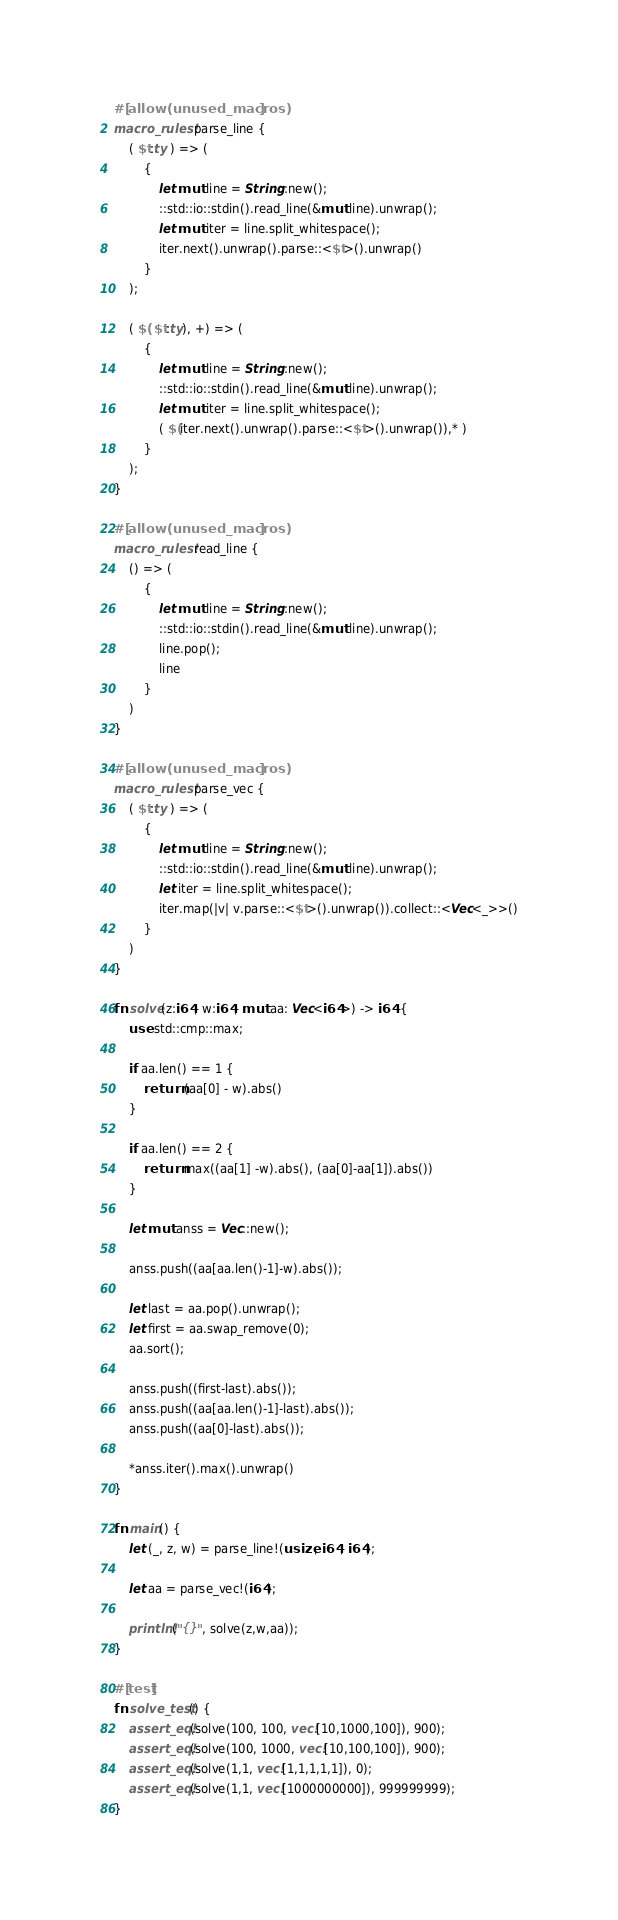<code> <loc_0><loc_0><loc_500><loc_500><_Rust_>#[allow(unused_macros)]
macro_rules! parse_line {
    ( $t:ty ) => (
        {
            let mut line = String::new();
            ::std::io::stdin().read_line(&mut line).unwrap();
            let mut iter = line.split_whitespace();
            iter.next().unwrap().parse::<$t>().unwrap()
        }
    );

    ( $( $t:ty), +) => (
        {
            let mut line = String::new();
            ::std::io::stdin().read_line(&mut line).unwrap();
            let mut iter = line.split_whitespace();
            ( $(iter.next().unwrap().parse::<$t>().unwrap()),* )
        }
    );
}

#[allow(unused_macros)]
macro_rules! read_line {
    () => (
        {
            let mut line = String::new();
            ::std::io::stdin().read_line(&mut line).unwrap();
            line.pop();
            line
        }
    )
}

#[allow(unused_macros)]
macro_rules! parse_vec {
    ( $t:ty ) => (
        {
            let mut line = String::new();
            ::std::io::stdin().read_line(&mut line).unwrap();
            let iter = line.split_whitespace();
            iter.map(|v| v.parse::<$t>().unwrap()).collect::<Vec<_>>()
        }
    )
}

fn solve(z:i64, w:i64, mut aa: Vec<i64>) -> i64 {
    use std::cmp::max;

    if aa.len() == 1 {
        return (aa[0] - w).abs()
    }

    if aa.len() == 2 {
        return max((aa[1] -w).abs(), (aa[0]-aa[1]).abs())
    }

    let mut anss = Vec::new();

    anss.push((aa[aa.len()-1]-w).abs());

    let last = aa.pop().unwrap();
    let first = aa.swap_remove(0);
    aa.sort();

    anss.push((first-last).abs());
    anss.push((aa[aa.len()-1]-last).abs());
    anss.push((aa[0]-last).abs());

    *anss.iter().max().unwrap()
}

fn main() {
    let (_, z, w) = parse_line!(usize, i64, i64);

    let aa = parse_vec!(i64);

    println!("{}", solve(z,w,aa));
}

#[test]
fn solve_test() {
    assert_eq!(solve(100, 100, vec![10,1000,100]), 900);
    assert_eq!(solve(100, 1000, vec![10,100,100]), 900);
    assert_eq!(solve(1,1, vec![1,1,1,1,1]), 0);
    assert_eq!(solve(1,1, vec![1000000000]), 999999999);
}
</code> 